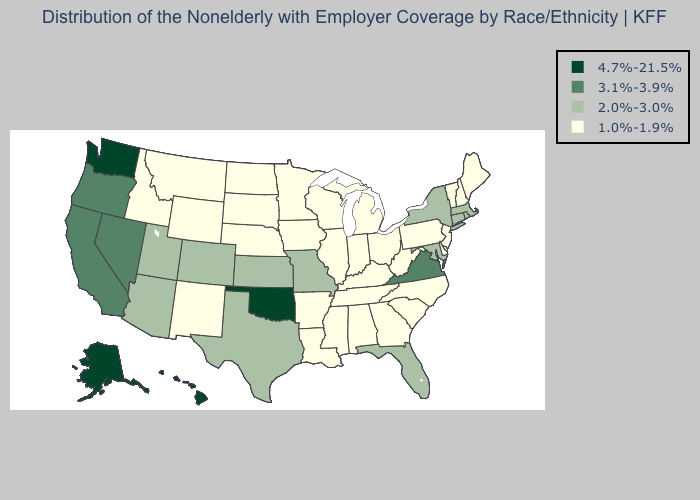Name the states that have a value in the range 4.7%-21.5%?
Be succinct. Alaska, Hawaii, Oklahoma, Washington. Which states have the lowest value in the USA?
Concise answer only. Alabama, Arkansas, Delaware, Georgia, Idaho, Illinois, Indiana, Iowa, Kentucky, Louisiana, Maine, Michigan, Minnesota, Mississippi, Montana, Nebraska, New Hampshire, New Jersey, New Mexico, North Carolina, North Dakota, Ohio, Pennsylvania, South Carolina, South Dakota, Tennessee, Vermont, West Virginia, Wisconsin, Wyoming. Does the map have missing data?
Concise answer only. No. Does the first symbol in the legend represent the smallest category?
Short answer required. No. Name the states that have a value in the range 2.0%-3.0%?
Answer briefly. Arizona, Colorado, Connecticut, Florida, Kansas, Maryland, Massachusetts, Missouri, New York, Rhode Island, Texas, Utah. Does Kansas have the lowest value in the USA?
Short answer required. No. What is the lowest value in states that border Ohio?
Answer briefly. 1.0%-1.9%. Among the states that border Illinois , which have the highest value?
Quick response, please. Missouri. Name the states that have a value in the range 4.7%-21.5%?
Answer briefly. Alaska, Hawaii, Oklahoma, Washington. Among the states that border New Mexico , does Oklahoma have the lowest value?
Quick response, please. No. What is the highest value in the South ?
Keep it brief. 4.7%-21.5%. Name the states that have a value in the range 1.0%-1.9%?
Concise answer only. Alabama, Arkansas, Delaware, Georgia, Idaho, Illinois, Indiana, Iowa, Kentucky, Louisiana, Maine, Michigan, Minnesota, Mississippi, Montana, Nebraska, New Hampshire, New Jersey, New Mexico, North Carolina, North Dakota, Ohio, Pennsylvania, South Carolina, South Dakota, Tennessee, Vermont, West Virginia, Wisconsin, Wyoming. What is the value of Florida?
Write a very short answer. 2.0%-3.0%. What is the lowest value in the Northeast?
Quick response, please. 1.0%-1.9%. What is the value of Nebraska?
Keep it brief. 1.0%-1.9%. 